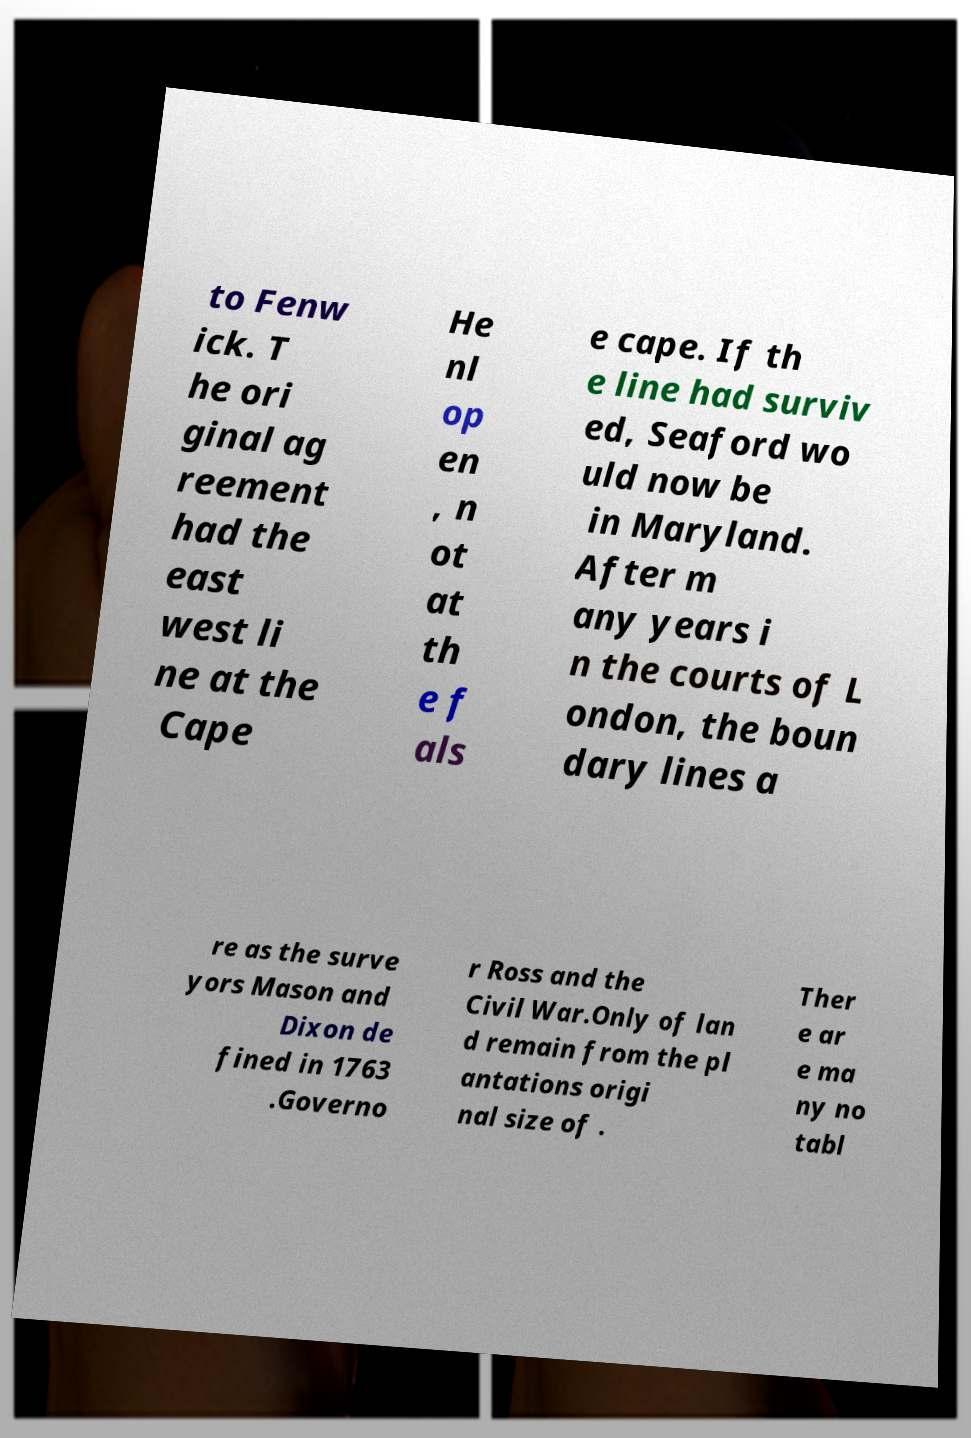Could you assist in decoding the text presented in this image and type it out clearly? to Fenw ick. T he ori ginal ag reement had the east west li ne at the Cape He nl op en , n ot at th e f als e cape. If th e line had surviv ed, Seaford wo uld now be in Maryland. After m any years i n the courts of L ondon, the boun dary lines a re as the surve yors Mason and Dixon de fined in 1763 .Governo r Ross and the Civil War.Only of lan d remain from the pl antations origi nal size of . Ther e ar e ma ny no tabl 